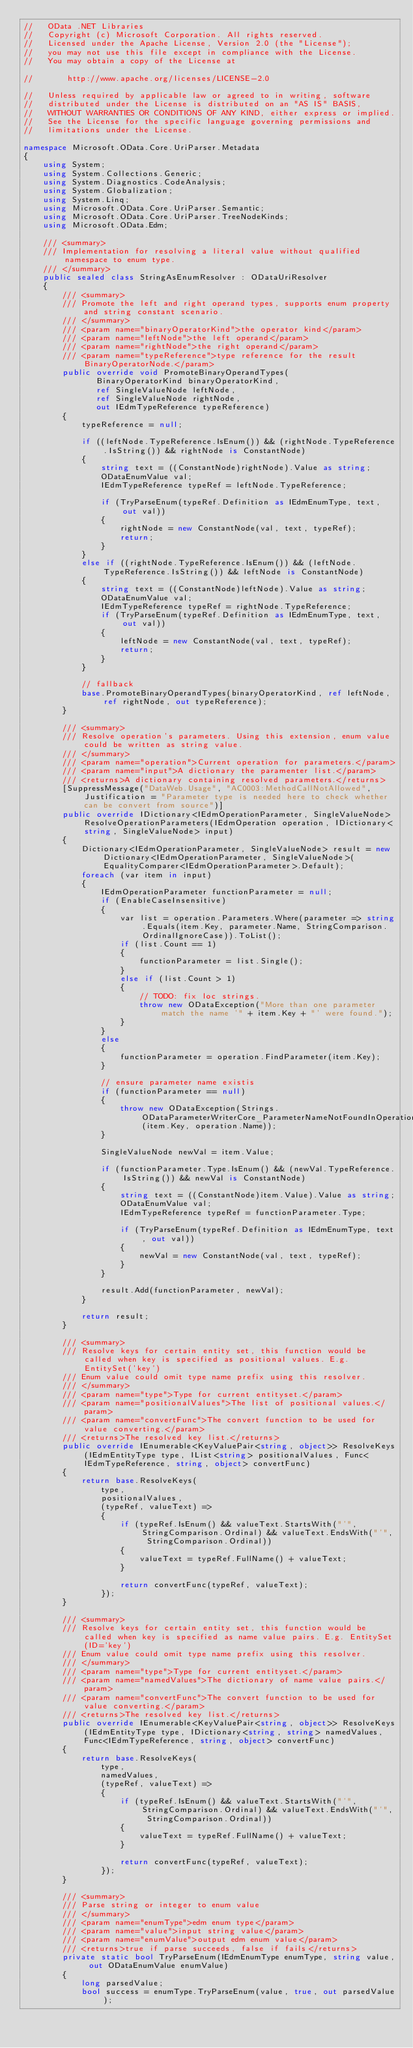Convert code to text. <code><loc_0><loc_0><loc_500><loc_500><_C#_>//   OData .NET Libraries
//   Copyright (c) Microsoft Corporation. All rights reserved.  
//   Licensed under the Apache License, Version 2.0 (the "License");
//   you may not use this file except in compliance with the License.
//   You may obtain a copy of the License at

//       http://www.apache.org/licenses/LICENSE-2.0

//   Unless required by applicable law or agreed to in writing, software
//   distributed under the License is distributed on an "AS IS" BASIS,
//   WITHOUT WARRANTIES OR CONDITIONS OF ANY KIND, either express or implied.
//   See the License for the specific language governing permissions and
//   limitations under the License.

namespace Microsoft.OData.Core.UriParser.Metadata
{
    using System;
    using System.Collections.Generic;
    using System.Diagnostics.CodeAnalysis;
    using System.Globalization;
    using System.Linq;
    using Microsoft.OData.Core.UriParser.Semantic;
    using Microsoft.OData.Core.UriParser.TreeNodeKinds;
    using Microsoft.OData.Edm;

    /// <summary>
    /// Implementation for resolving a literal value without qualified namespace to enum type.
    /// </summary>
    public sealed class StringAsEnumResolver : ODataUriResolver
    {
        /// <summary>
        /// Promote the left and right operand types, supports enum property and string constant scenario.
        /// </summary>
        /// <param name="binaryOperatorKind">the operator kind</param>
        /// <param name="leftNode">the left operand</param>
        /// <param name="rightNode">the right operand</param>
        /// <param name="typeReference">type reference for the result BinaryOperatorNode.</param>
        public override void PromoteBinaryOperandTypes(
               BinaryOperatorKind binaryOperatorKind,
               ref SingleValueNode leftNode,
               ref SingleValueNode rightNode,
               out IEdmTypeReference typeReference)
        {
            typeReference = null;

            if ((leftNode.TypeReference.IsEnum()) && (rightNode.TypeReference.IsString()) && rightNode is ConstantNode)
            {
                string text = ((ConstantNode)rightNode).Value as string;
                ODataEnumValue val;
                IEdmTypeReference typeRef = leftNode.TypeReference;

                if (TryParseEnum(typeRef.Definition as IEdmEnumType, text, out val))
                {
                    rightNode = new ConstantNode(val, text, typeRef);
                    return;
                }
            }
            else if ((rightNode.TypeReference.IsEnum()) && (leftNode.TypeReference.IsString()) && leftNode is ConstantNode)
            {
                string text = ((ConstantNode)leftNode).Value as string;
                ODataEnumValue val;
                IEdmTypeReference typeRef = rightNode.TypeReference;
                if (TryParseEnum(typeRef.Definition as IEdmEnumType, text, out val))
                {
                    leftNode = new ConstantNode(val, text, typeRef);
                    return;
                }
            }

            // fallback
            base.PromoteBinaryOperandTypes(binaryOperatorKind, ref leftNode, ref rightNode, out typeReference);
        }

        /// <summary>
        /// Resolve operation's parameters. Using this extension, enum value could be written as string value.
        /// </summary>
        /// <param name="operation">Current operation for parameters.</param>
        /// <param name="input">A dictionary the paramenter list.</param>
        /// <returns>A dictionary containing resolved parameters.</returns>
        [SuppressMessage("DataWeb.Usage", "AC0003:MethodCallNotAllowed", Justification = "Parameter type is needed here to check whether can be convert from source")]
        public override IDictionary<IEdmOperationParameter, SingleValueNode> ResolveOperationParameters(IEdmOperation operation, IDictionary<string, SingleValueNode> input)
        {
            Dictionary<IEdmOperationParameter, SingleValueNode> result = new Dictionary<IEdmOperationParameter, SingleValueNode>(EqualityComparer<IEdmOperationParameter>.Default);
            foreach (var item in input)
            {
                IEdmOperationParameter functionParameter = null;
                if (EnableCaseInsensitive)
                {
                    var list = operation.Parameters.Where(parameter => string.Equals(item.Key, parameter.Name, StringComparison.OrdinalIgnoreCase)).ToList();
                    if (list.Count == 1)
                    {
                        functionParameter = list.Single();
                    }
                    else if (list.Count > 1)
                    {
                        // TODO: fix loc strings.
                        throw new ODataException("More than one parameter match the name '" + item.Key + "' were found.");
                    }
                }
                else
                {
                    functionParameter = operation.FindParameter(item.Key);
                }

                // ensure parameter name existis
                if (functionParameter == null)
                {
                    throw new ODataException(Strings.ODataParameterWriterCore_ParameterNameNotFoundInOperation(item.Key, operation.Name));
                }

                SingleValueNode newVal = item.Value;

                if (functionParameter.Type.IsEnum() && (newVal.TypeReference.IsString()) && newVal is ConstantNode)
                {
                    string text = ((ConstantNode)item.Value).Value as string;
                    ODataEnumValue val;
                    IEdmTypeReference typeRef = functionParameter.Type;

                    if (TryParseEnum(typeRef.Definition as IEdmEnumType, text, out val))
                    {
                        newVal = new ConstantNode(val, text, typeRef);
                    }
                }

                result.Add(functionParameter, newVal);
            }

            return result;
        }

        /// <summary>
        /// Resolve keys for certain entity set, this function would be called when key is specified as positional values. E.g. EntitySet('key')
        /// Enum value could omit type name prefix using this resolver.
        /// </summary>
        /// <param name="type">Type for current entityset.</param>
        /// <param name="positionalValues">The list of positional values.</param>
        /// <param name="convertFunc">The convert function to be used for value converting.</param>
        /// <returns>The resolved key list.</returns>
        public override IEnumerable<KeyValuePair<string, object>> ResolveKeys(IEdmEntityType type, IList<string> positionalValues, Func<IEdmTypeReference, string, object> convertFunc)
        {
            return base.ResolveKeys(
                type,
                positionalValues,
                (typeRef, valueText) =>
                {
                    if (typeRef.IsEnum() && valueText.StartsWith("'", StringComparison.Ordinal) && valueText.EndsWith("'", StringComparison.Ordinal))
                    {
                        valueText = typeRef.FullName() + valueText;
                    }

                    return convertFunc(typeRef, valueText);
                });
        }

        /// <summary>
        /// Resolve keys for certain entity set, this function would be called when key is specified as name value pairs. E.g. EntitySet(ID='key')
        /// Enum value could omit type name prefix using this resolver.
        /// </summary>
        /// <param name="type">Type for current entityset.</param>
        /// <param name="namedValues">The dictionary of name value pairs.</param>
        /// <param name="convertFunc">The convert function to be used for value converting.</param>
        /// <returns>The resolved key list.</returns>
        public override IEnumerable<KeyValuePair<string, object>> ResolveKeys(IEdmEntityType type, IDictionary<string, string> namedValues, Func<IEdmTypeReference, string, object> convertFunc)
        {
            return base.ResolveKeys(
                type,
                namedValues,
                (typeRef, valueText) =>
                {
                    if (typeRef.IsEnum() && valueText.StartsWith("'", StringComparison.Ordinal) && valueText.EndsWith("'", StringComparison.Ordinal))
                    {
                        valueText = typeRef.FullName() + valueText;
                    }

                    return convertFunc(typeRef, valueText);
                });
        }

        /// <summary>
        /// Parse string or integer to enum value
        /// </summary>
        /// <param name="enumType">edm enum type</param>
        /// <param name="value">input string value</param>
        /// <param name="enumValue">output edm enum value</param>
        /// <returns>true if parse succeeds, false if fails</returns>
        private static bool TryParseEnum(IEdmEnumType enumType, string value, out ODataEnumValue enumValue)
        {
            long parsedValue;
            bool success = enumType.TryParseEnum(value, true, out parsedValue);</code> 